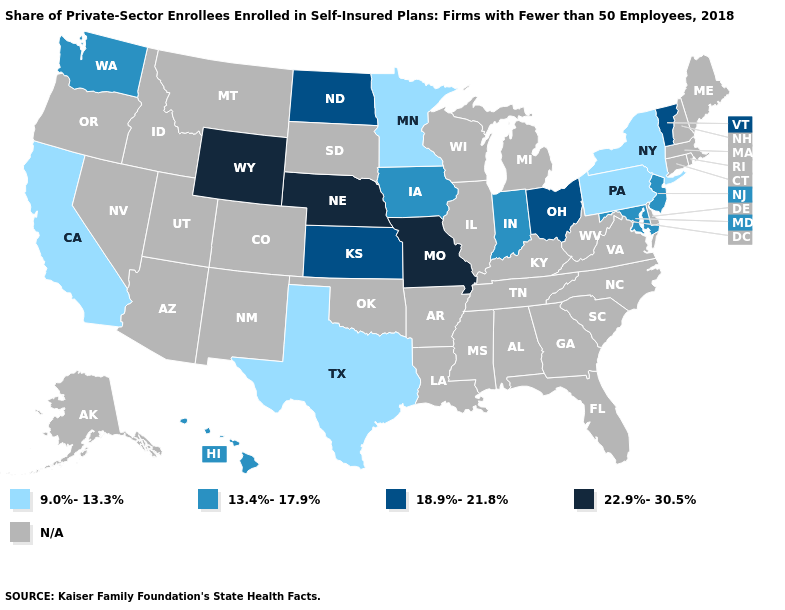Does California have the lowest value in the USA?
Quick response, please. Yes. Name the states that have a value in the range 18.9%-21.8%?
Be succinct. Kansas, North Dakota, Ohio, Vermont. What is the value of Virginia?
Concise answer only. N/A. Among the states that border Colorado , which have the lowest value?
Short answer required. Kansas. What is the value of Idaho?
Give a very brief answer. N/A. What is the lowest value in the USA?
Concise answer only. 9.0%-13.3%. Name the states that have a value in the range 22.9%-30.5%?
Concise answer only. Missouri, Nebraska, Wyoming. Which states have the lowest value in the USA?
Short answer required. California, Minnesota, New York, Pennsylvania, Texas. Name the states that have a value in the range 22.9%-30.5%?
Concise answer only. Missouri, Nebraska, Wyoming. Which states hav the highest value in the West?
Concise answer only. Wyoming. Does Nebraska have the highest value in the USA?
Give a very brief answer. Yes. What is the value of Tennessee?
Keep it brief. N/A. 